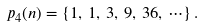Convert formula to latex. <formula><loc_0><loc_0><loc_500><loc_500>p _ { 4 } ( n ) = \{ 1 , \, 1 , \, 3 , \, 9 , \, 3 6 , \, \cdots \} \, .</formula> 